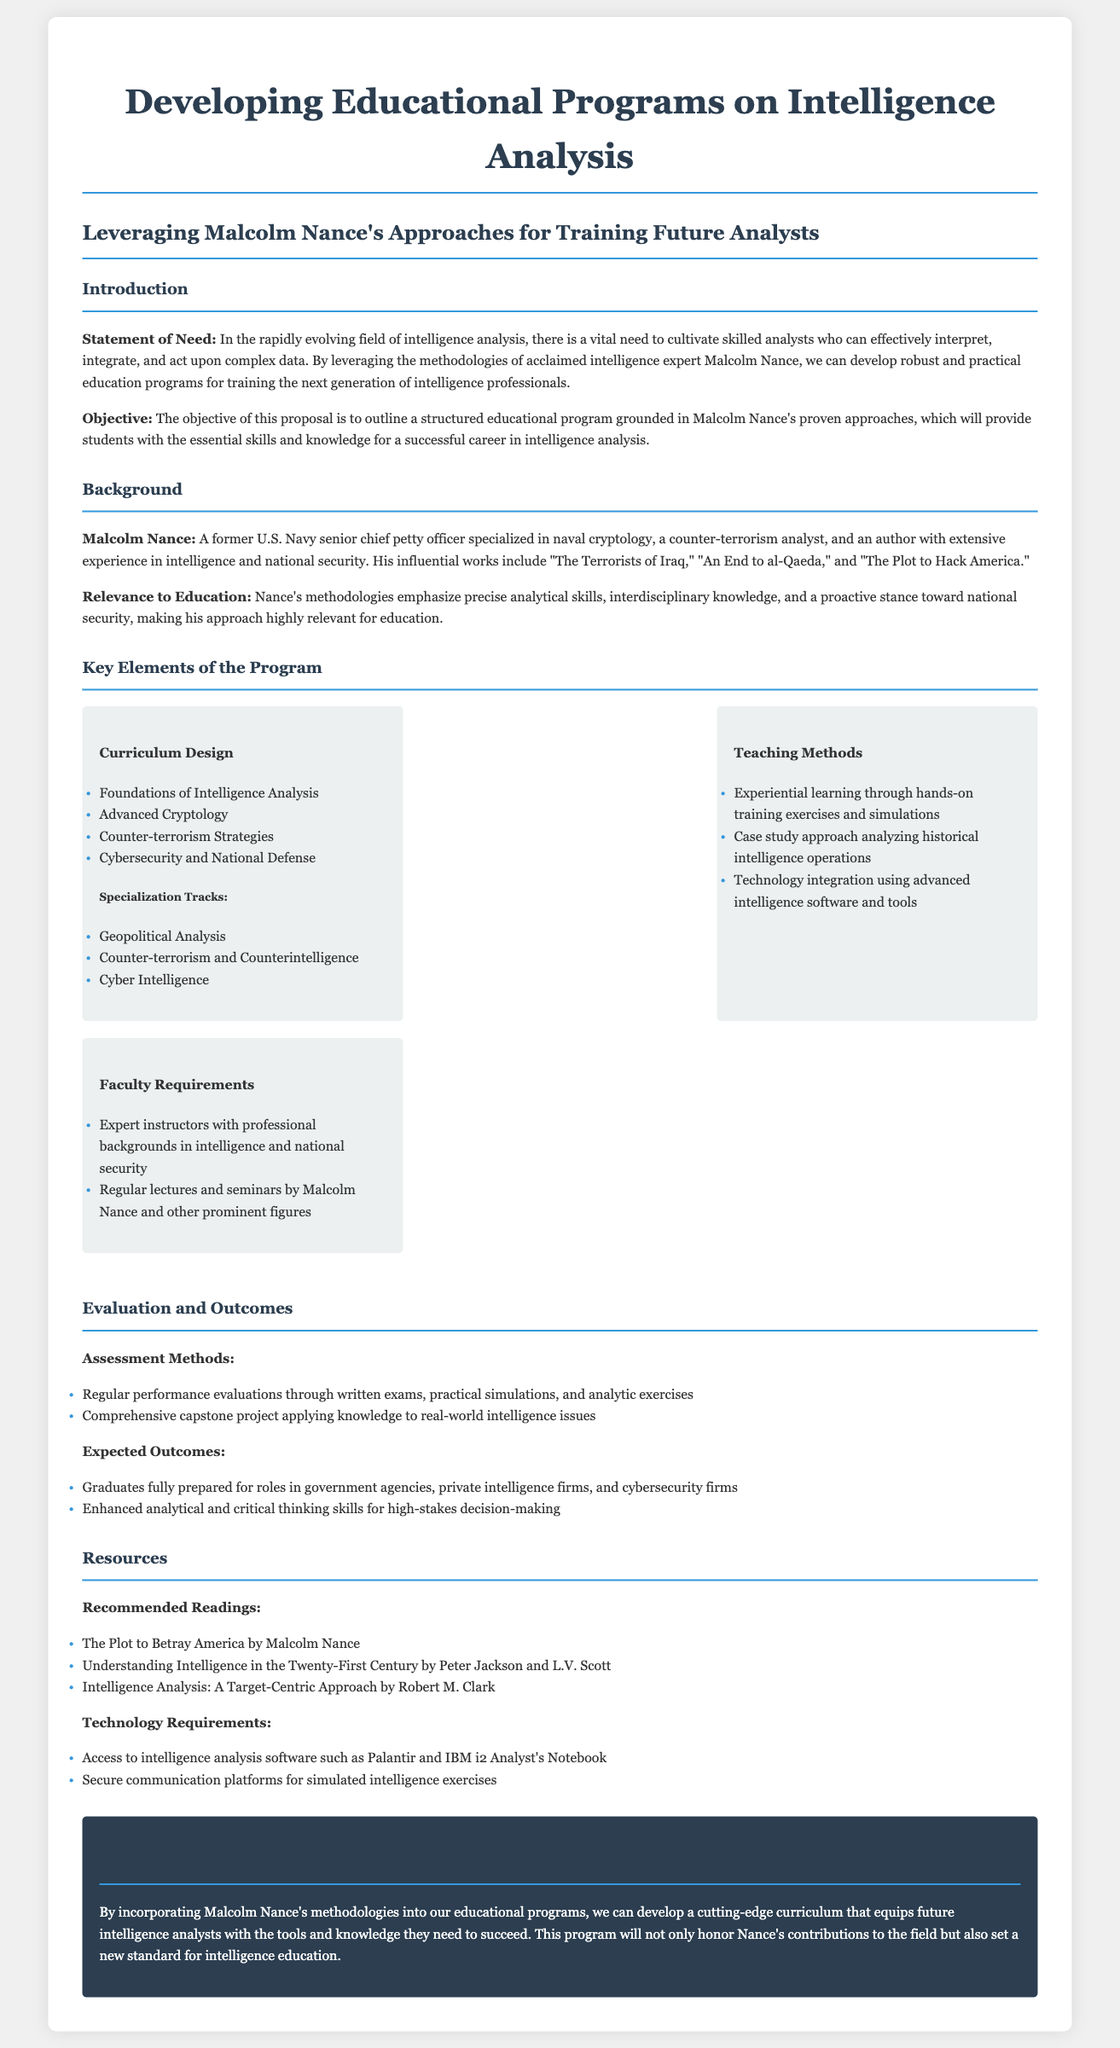what is the title of the proposal? The title of the proposal is the main heading that summarizes the purpose of the document.
Answer: Developing Educational Programs on Intelligence Analysis who is the key figure referenced in the proposal? The key figure referenced in the proposal is Malcolm Nance, who is noted for his contributions to intelligence and national security.
Answer: Malcolm Nance what is one of the specialization tracks mentioned in the program? The proposal outlines specific areas of focus within the educational program, which are categorized as specialization tracks.
Answer: Counter-terrorism and Counterintelligence how will students' performance be evaluated? The document details various assessment techniques to ensure students acquire the necessary skills for intelligence analysis.
Answer: Regular performance evaluations what is one expected outcome for graduates of the program? The proposal presents anticipated results from the educational program, particularly regarding the graduates' readiness for professional roles.
Answer: Graduates fully prepared for roles in government agencies what type of learning method is emphasized in the program? The proposal describes a specific pedagogical approach to impart knowledge and skills relevant to intelligence analysis.
Answer: Experiential learning what is the relevance of Malcolm Nance's methodologies to education? The document explains the importance of Nance's approaches in context to developing analytical expertise in students.
Answer: Precise analytical skills who are the faculty requirements mentioned in the proposal? The document specifies the qualifications and backgrounds expected of instructors involved in the proposed educational program.
Answer: Expert instructors with professional backgrounds in intelligence 